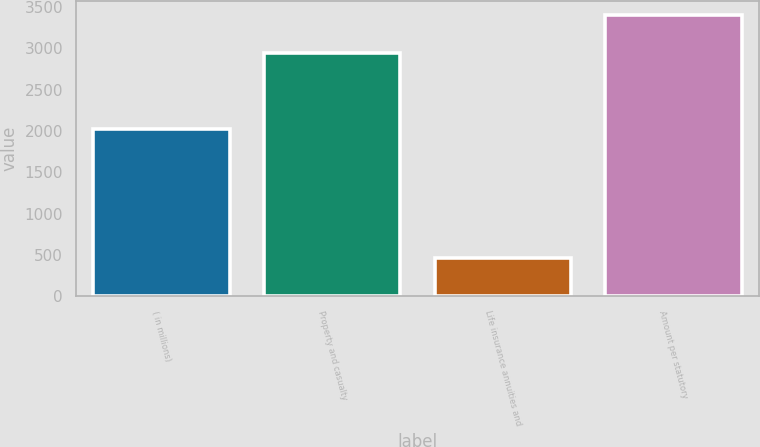<chart> <loc_0><loc_0><loc_500><loc_500><bar_chart><fcel>( in millions)<fcel>Property and casualty<fcel>Life insurance annuities and<fcel>Amount per statutory<nl><fcel>2018<fcel>2939<fcel>465<fcel>3404<nl></chart> 